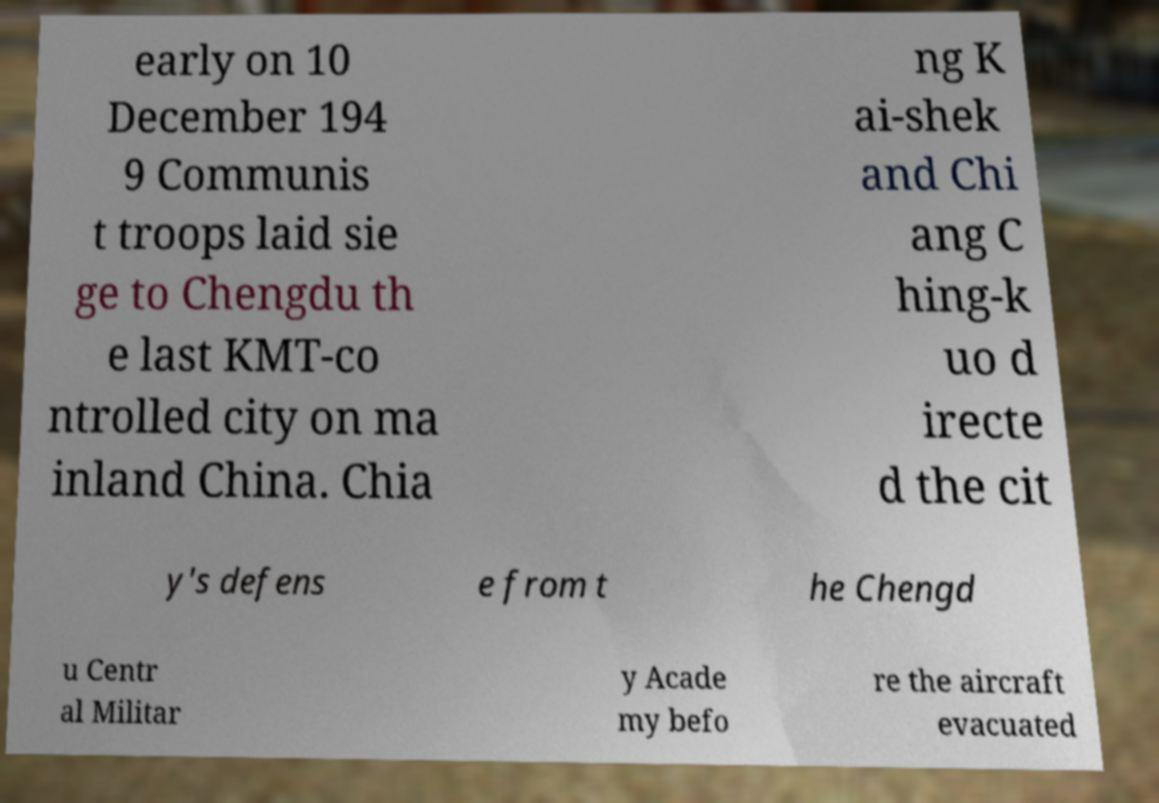For documentation purposes, I need the text within this image transcribed. Could you provide that? early on 10 December 194 9 Communis t troops laid sie ge to Chengdu th e last KMT-co ntrolled city on ma inland China. Chia ng K ai-shek and Chi ang C hing-k uo d irecte d the cit y's defens e from t he Chengd u Centr al Militar y Acade my befo re the aircraft evacuated 